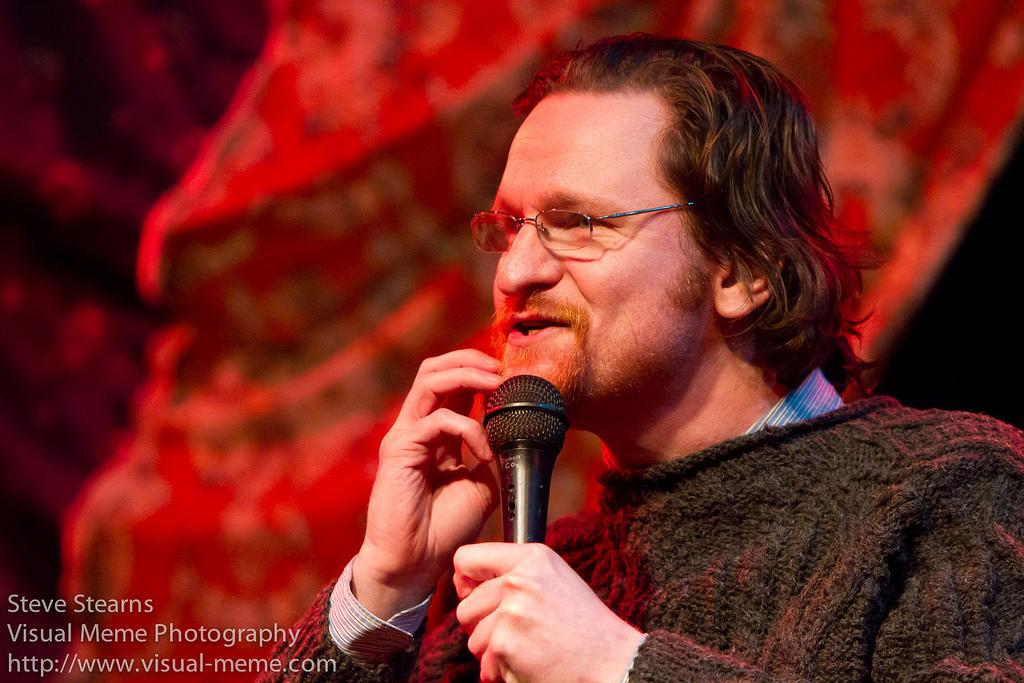Who is the main subject in the picture? There is a man in the picture. How is the man in the picture being emphasized? The man is highlighted in the picture. What accessory is the man wearing? The man is wearing spectacles. What is the man holding in the picture? The man is holding a mic. What type of feast is the man preparing in the image? There is no indication of a feast or any food preparation in the image; the man is holding a mic. How does the man push the beam in the image? There is no beam present in the image, so the man cannot push it. 